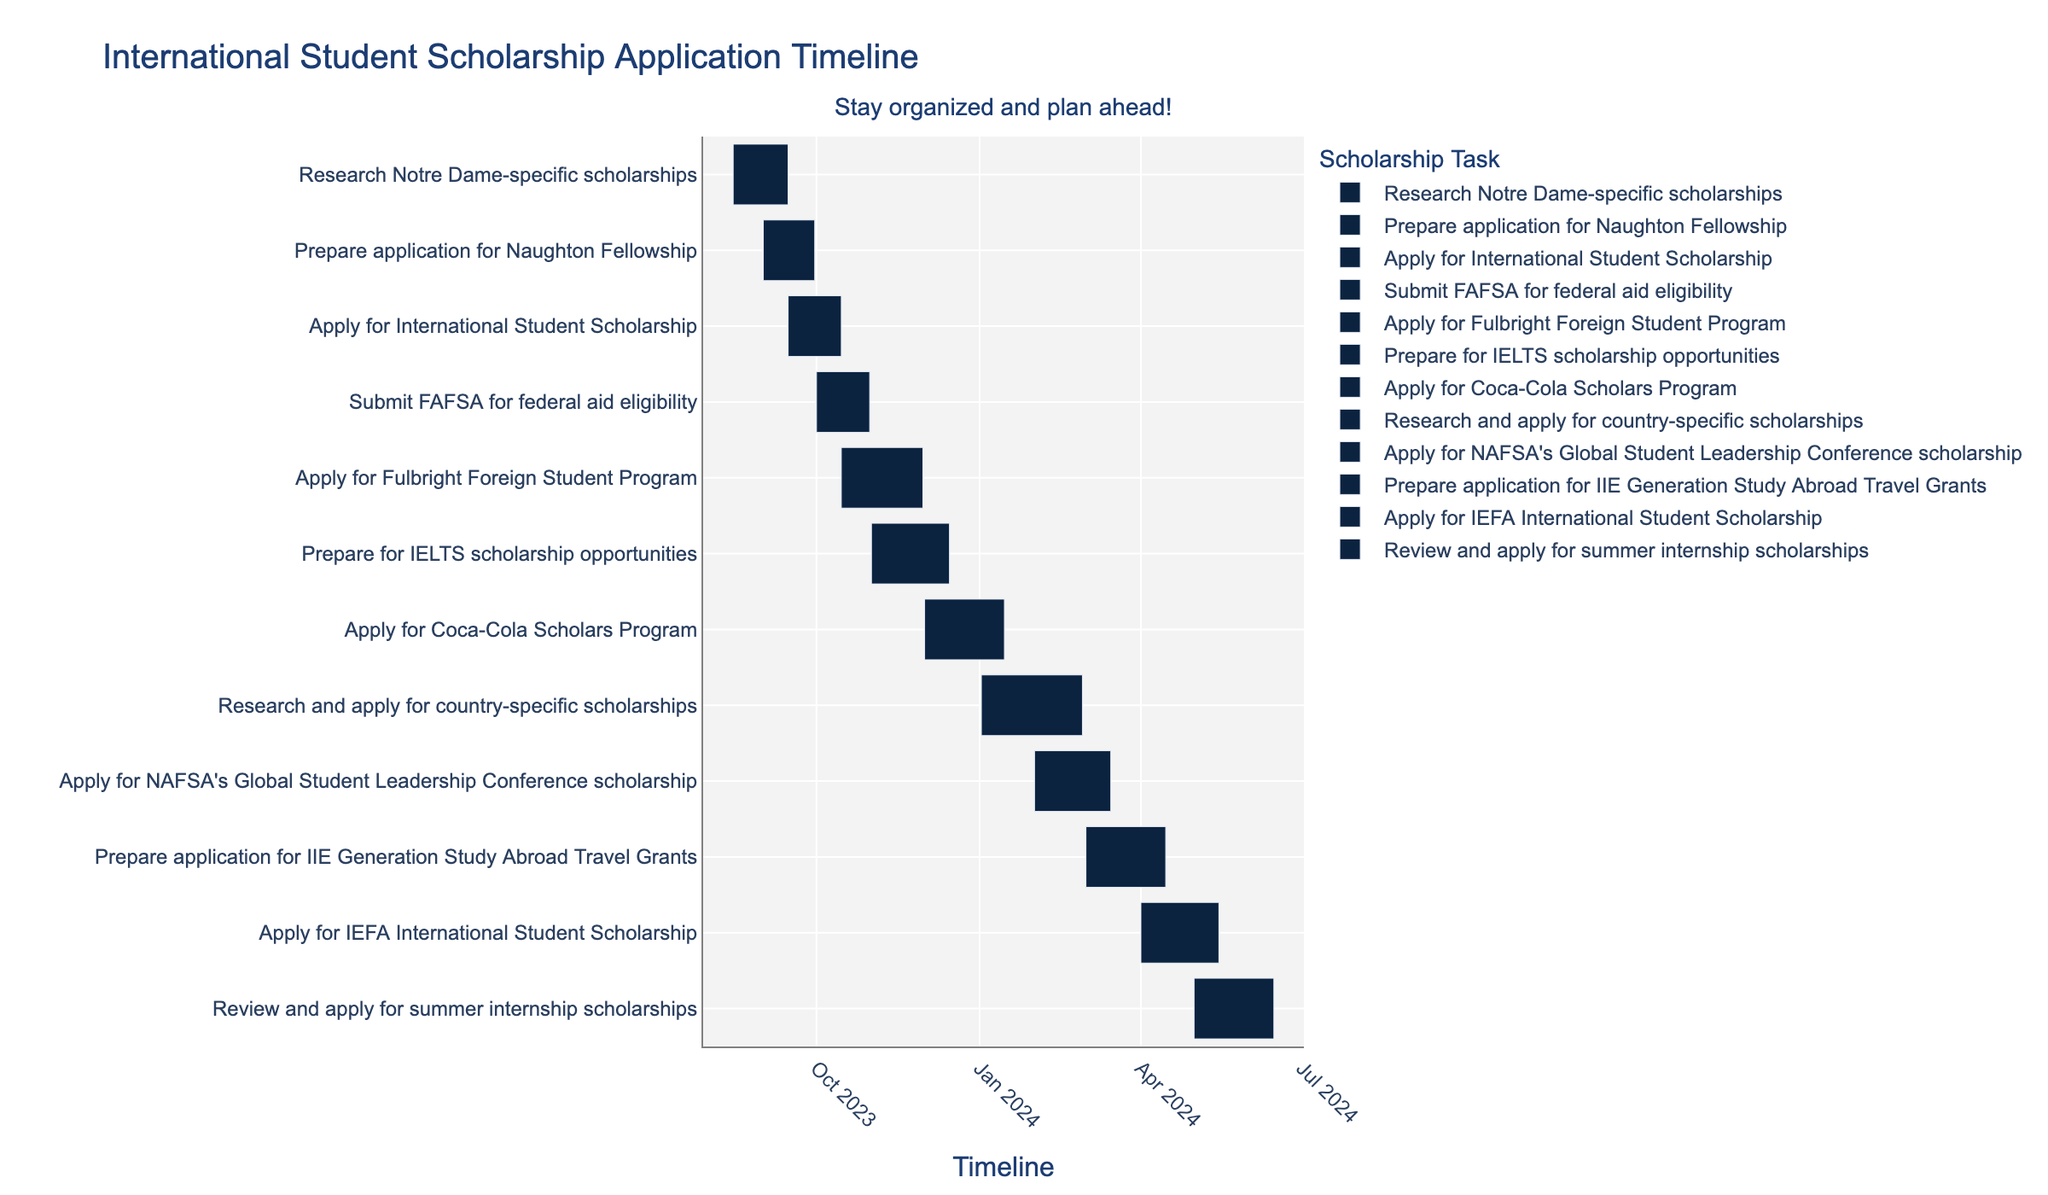What is the title of the Gantt Chart? The title is displayed at the top of the chart in a larger font size. It usually provides an overview of what the chart represents.
Answer: International Student Scholarship Application Timeline Which task has the longest duration in the Gantt Chart? To determine the task with the longest duration, look at the length of the bars. The longest bar represents the task with the longest duration. The task "Research and apply for country-specific scholarships" spans from January 2, 2024, to February 28, 2024.
Answer: Research and apply for country-specific scholarships How many tasks are there to prepare applications specifically for scholarships? Count the tasks which include "prepare application" in their description. These tasks are "Prepare application for Naughton Fellowship" and "Prepare application for IIE Generation Study Abroad Travel Grants".
Answer: 2 Which tasks overlap with each other in October? To find overlapping tasks in October, examine the bars that fall within the October time frame. The tasks "Submit FAFSA for federal aid eligibility" (October 1 to October 31) and "Apply for Fulbright Foreign Student Program" (October 15 to November 30) overlap in October.
Answer: Submit FAFSA for federal aid eligibility and Apply for Fulbright Foreign Student Program How long is the task "Prepare for IELTS scholarship opportunities"? The duration is found by calculating the difference between the start and end dates. This task starts on November 1, 2023, and ends on December 15, 2023.
Answer: 45 days Which task starts first according to the Gantt Chart? Identify the task with the earliest start date by examining all the starting points of the bars. The earliest start date is August 15, 2023.
Answer: Research Notre Dame-specific scholarships How many tasks are scheduled to start in 2024? Count the tasks with a start date in 2024 by looking at the bars that begin after December 31, 2023. The tasks are "Research and apply for country-specific scholarships," "Apply for NAFSA's Global Student Leadership Conference scholarship," "Prepare application for IIE Generation Study Abroad Travel Grants," "Apply for IEFA International Student Scholarship," and "Review and apply for summer internship scholarships."
Answer: 5 Compare the total duration of the tasks in 2023 versus the tasks in 2024. Which year has more application time? Calculate the total duration of all tasks in each year and then compare the sums. In 2023: "Research Notre Dame-specific scholarships" (31 days), "Prepare application for Naughton Fellowship" (30 days), "Apply for International Student Scholarship" (30 days), "Submit FAFSA for federal aid eligibility" (31 days), "Apply for Fulbright Foreign Student Program" (46 days), "Prepare for IELTS scholarship opportunities" (45 days), "Apply for Coca-Cola Scholars Program" (46 days). In 2024: "Research and apply for country-specific scholarships" (58 days), "Apply for NAFSA's Global Student Leadership Conference scholarship" (43 days), "Prepare application for IIE Generation Study Abroad Travel Grants" (46 days), "Apply for IEFA International Student Scholarship" (45 days), "Review and apply for summer internship scholarships" (46 days). Total duration for 2023 is 259 days and for 2024 is 237 days.
Answer: 2023 What is the coloration pattern used in this figure? Observe the color of the bars representing different tasks. The description mentions using Notre Dame colors for the bars. These colors include several shades of blue, gold, teal, and green which help in distinguishing different tasks visually.
Answer: Notre Dame colors 